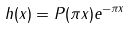<formula> <loc_0><loc_0><loc_500><loc_500>h ( x ) = P ( \pi x ) e ^ { - \pi x }</formula> 